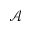<formula> <loc_0><loc_0><loc_500><loc_500>\mathcal { A }</formula> 